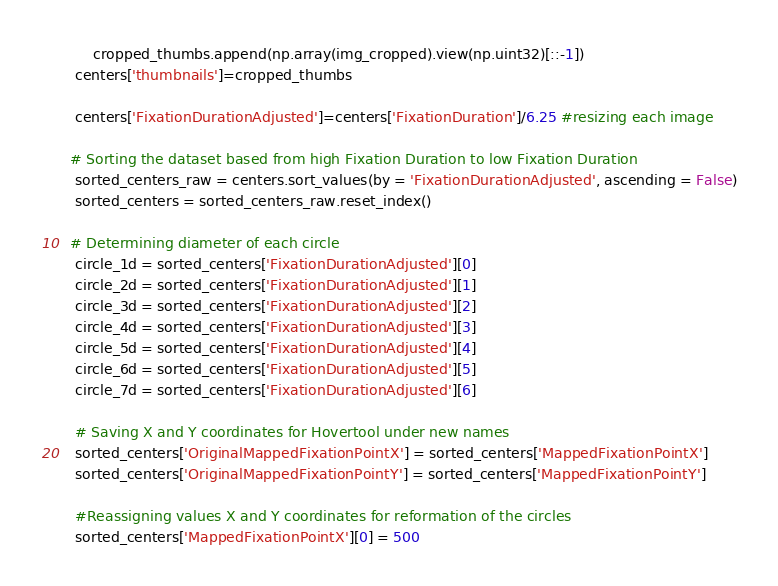Convert code to text. <code><loc_0><loc_0><loc_500><loc_500><_Python_>        cropped_thumbs.append(np.array(img_cropped).view(np.uint32)[::-1]) 
    centers['thumbnails']=cropped_thumbs

    centers['FixationDurationAdjusted']=centers['FixationDuration']/6.25 #resizing each image
   
   # Sorting the dataset based from high Fixation Duration to low Fixation Duration
    sorted_centers_raw = centers.sort_values(by = 'FixationDurationAdjusted', ascending = False)
    sorted_centers = sorted_centers_raw.reset_index()

   # Determining diameter of each circle
    circle_1d = sorted_centers['FixationDurationAdjusted'][0]
    circle_2d = sorted_centers['FixationDurationAdjusted'][1]
    circle_3d = sorted_centers['FixationDurationAdjusted'][2]
    circle_4d = sorted_centers['FixationDurationAdjusted'][3]
    circle_5d = sorted_centers['FixationDurationAdjusted'][4]
    circle_6d = sorted_centers['FixationDurationAdjusted'][5]
    circle_7d = sorted_centers['FixationDurationAdjusted'][6]

    # Saving X and Y coordinates for Hovertool under new names
    sorted_centers['OriginalMappedFixationPointX'] = sorted_centers['MappedFixationPointX']
    sorted_centers['OriginalMappedFixationPointY'] = sorted_centers['MappedFixationPointY']
    
    #Reassigning values X and Y coordinates for reformation of the circles
    sorted_centers['MappedFixationPointX'][0] = 500</code> 